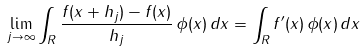<formula> <loc_0><loc_0><loc_500><loc_500>\lim _ { j \to \infty } \int _ { R } \frac { f ( x + h _ { j } ) - f ( x ) } { h _ { j } } \, \phi ( x ) \, d x = \int _ { R } f ^ { \prime } ( x ) \, \phi ( x ) \, d x</formula> 